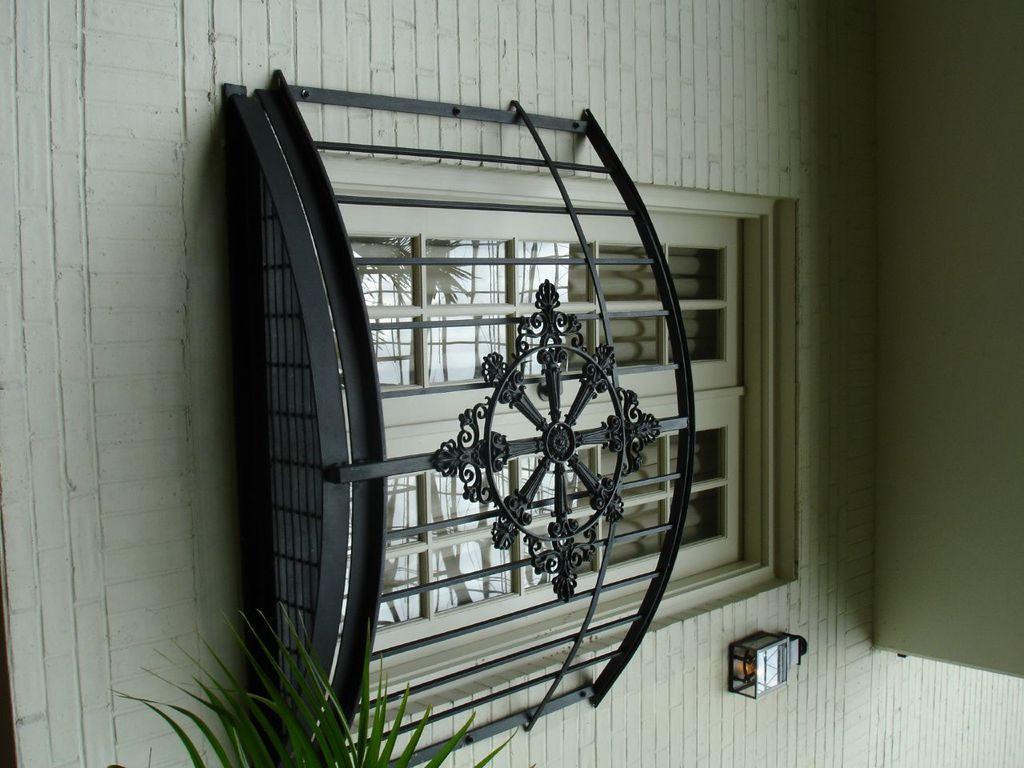Could you give a brief overview of what you see in this image? In this image I can see in the middle it is the glass window, at the bottom there are leaves. 